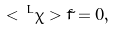<formula> <loc_0><loc_0><loc_500><loc_500>< \, ^ { L } \chi > \tilde { f } = 0 ,</formula> 